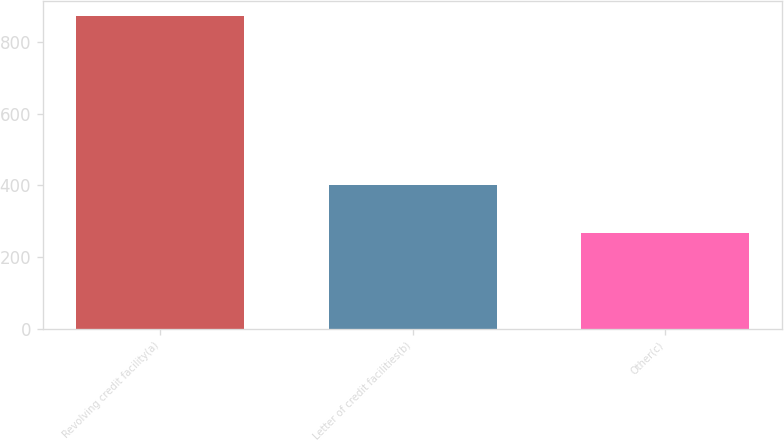<chart> <loc_0><loc_0><loc_500><loc_500><bar_chart><fcel>Revolving credit facility(a)<fcel>Letter of credit facilities(b)<fcel>Other(c)<nl><fcel>872<fcel>400<fcel>267<nl></chart> 